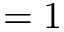Convert formula to latex. <formula><loc_0><loc_0><loc_500><loc_500>= 1</formula> 